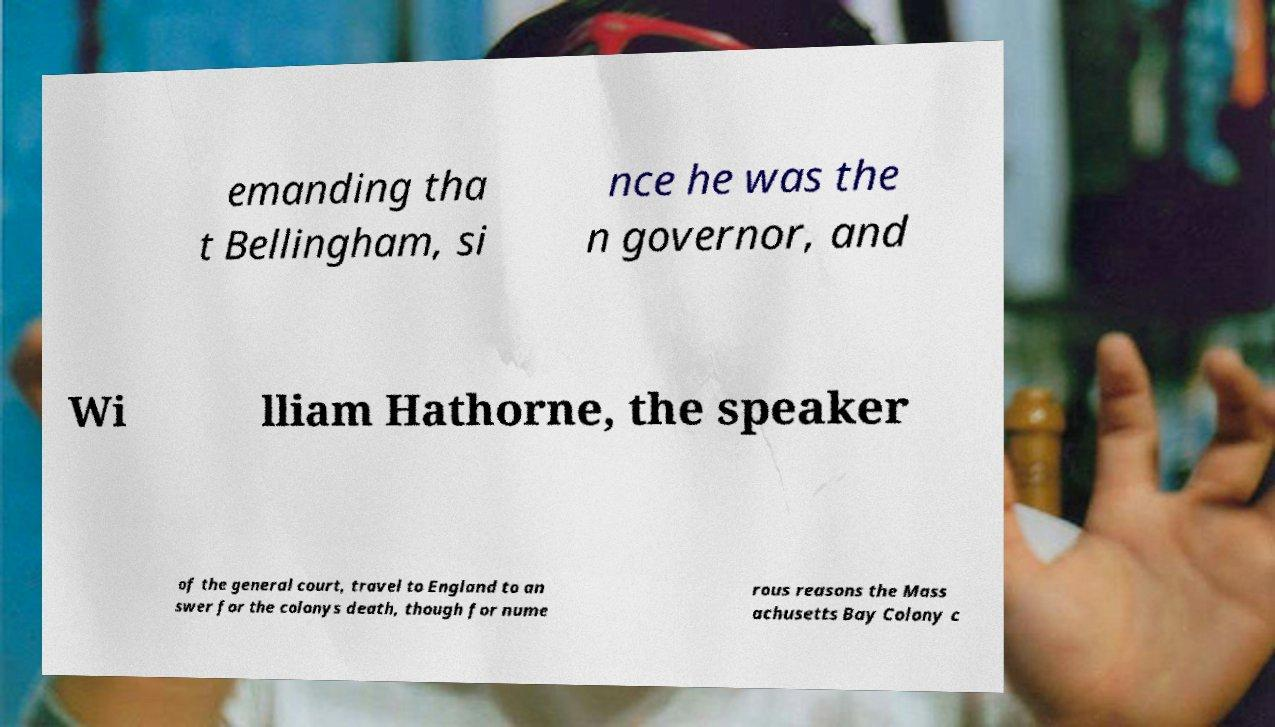Please identify and transcribe the text found in this image. emanding tha t Bellingham, si nce he was the n governor, and Wi lliam Hathorne, the speaker of the general court, travel to England to an swer for the colonys death, though for nume rous reasons the Mass achusetts Bay Colony c 